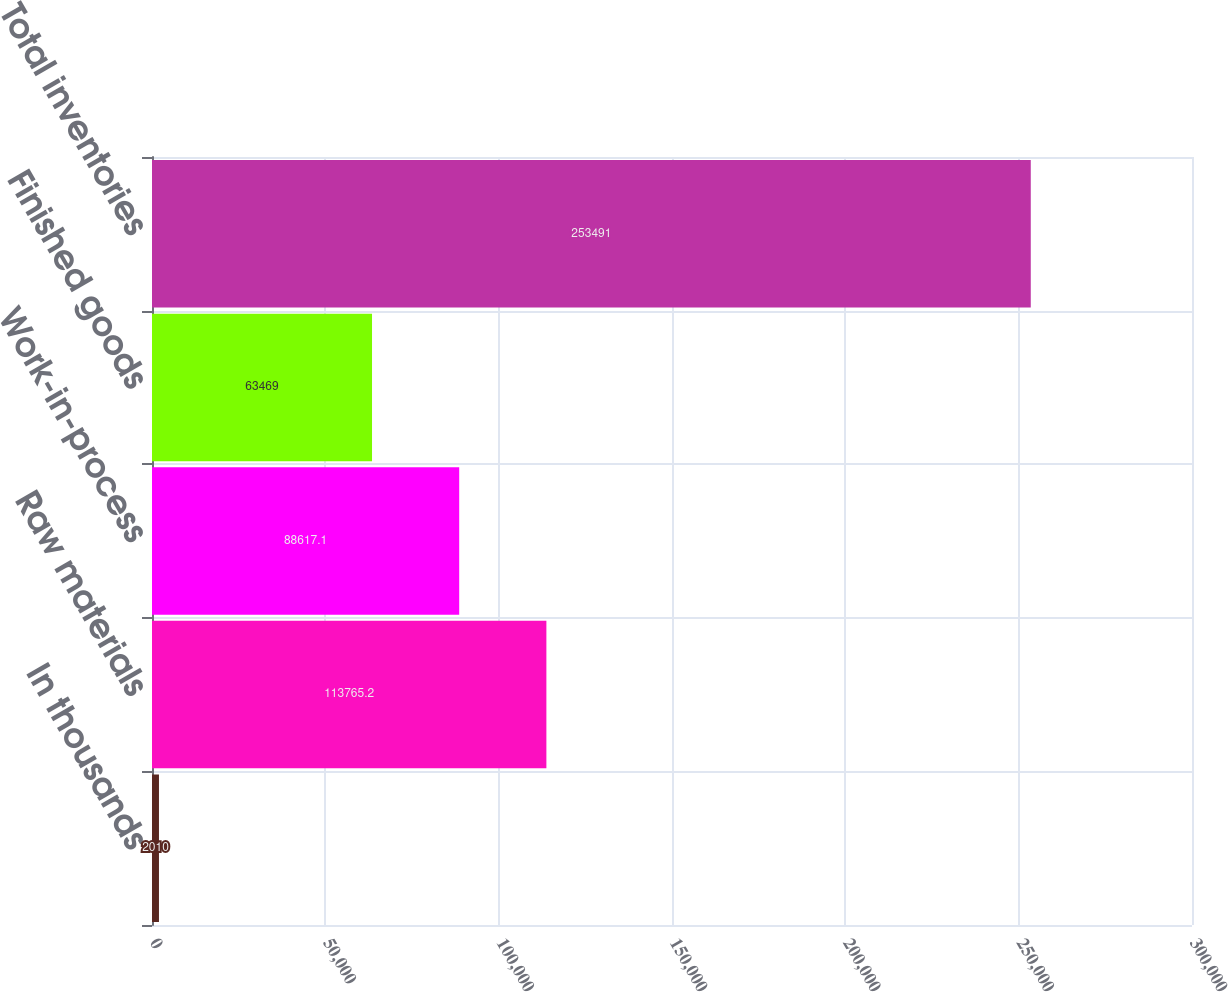Convert chart to OTSL. <chart><loc_0><loc_0><loc_500><loc_500><bar_chart><fcel>In thousands<fcel>Raw materials<fcel>Work-in-process<fcel>Finished goods<fcel>Total inventories<nl><fcel>2010<fcel>113765<fcel>88617.1<fcel>63469<fcel>253491<nl></chart> 